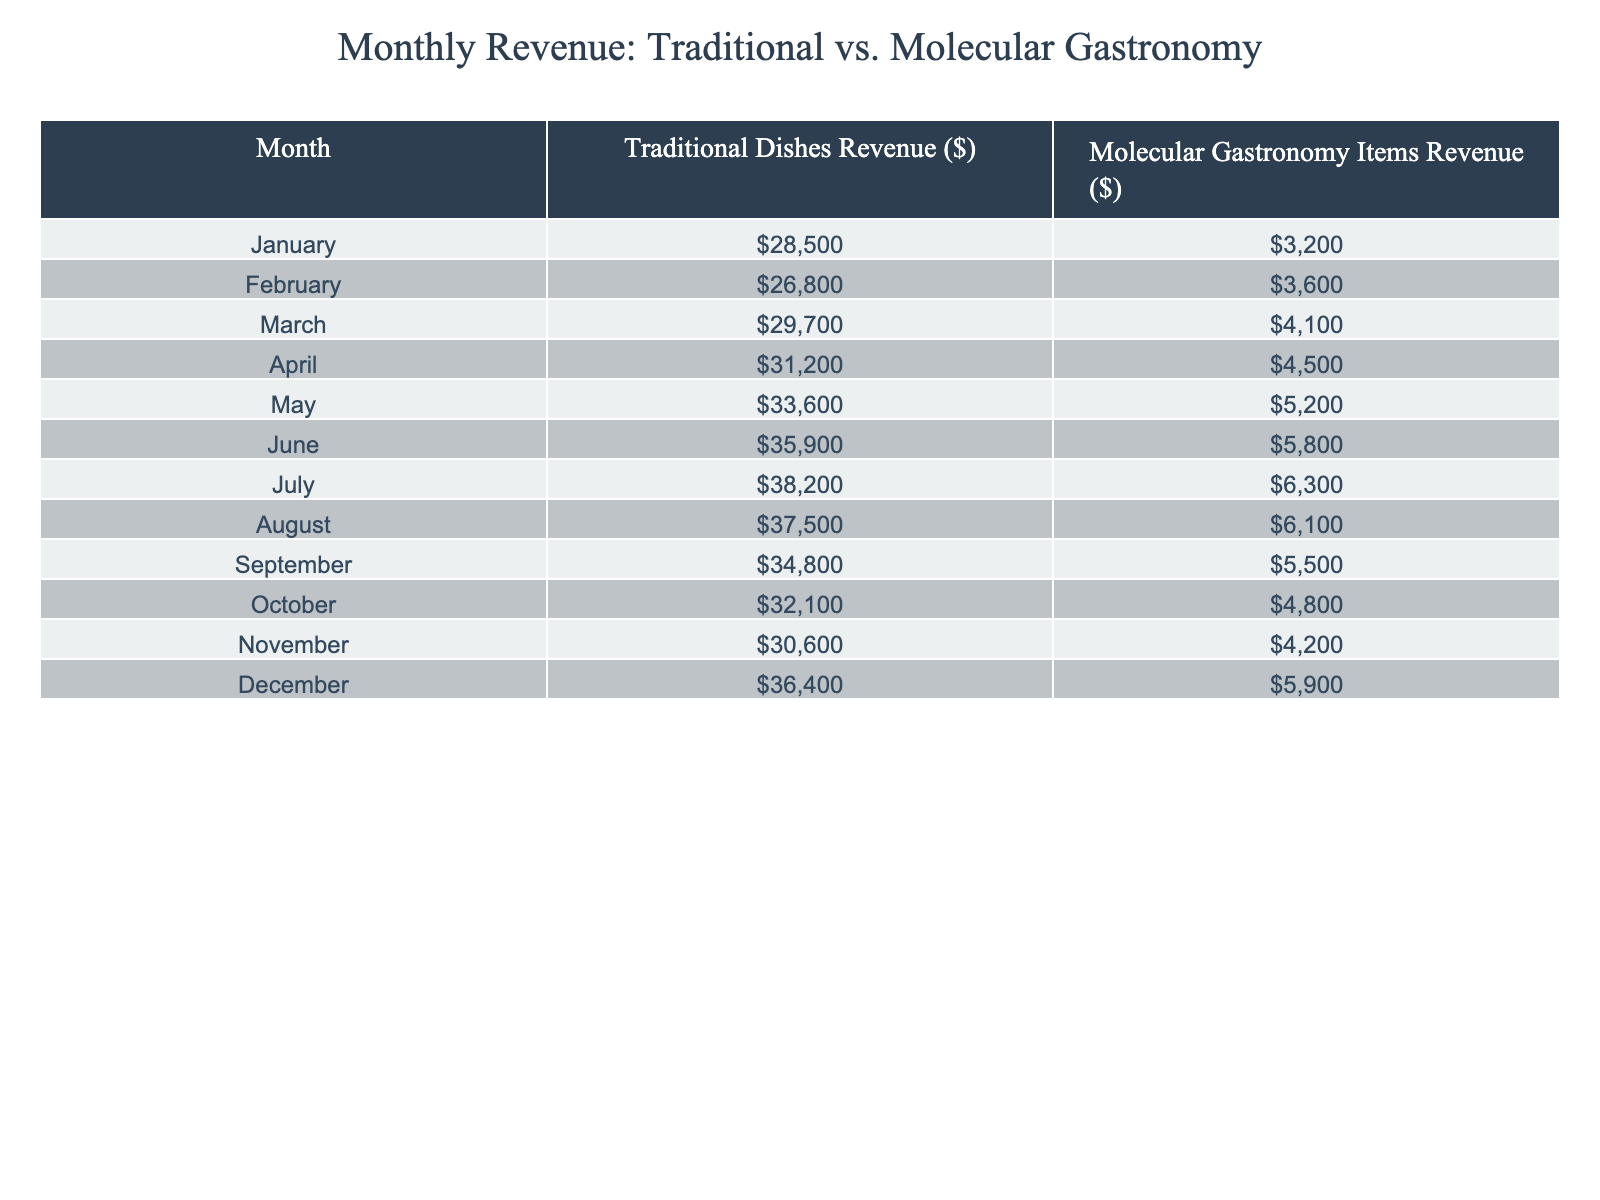What was the highest revenue month for traditional dishes? Looking at the data, the month with the highest revenue for traditional dishes is June, with a revenue of $35,900.
Answer: June What was the revenue of molecular gastronomy items in October? Referring to the table, the revenue for molecular gastronomy items in October is $4,800.
Answer: $4,800 What is the total revenue for traditional dishes over the entire year? To find the total revenue for traditional dishes, sum the monthly revenues: $28,500 + $26,800 + $29,700 + $31,200 + $33,600 + $35,900 + $38,200 + $37,500 + $34,800 + $32,100 + $30,600 + $36,400 = $401,400.
Answer: $401,400 What was the difference in revenue between traditional dishes and molecular gastronomy items in July? In July, the revenue for traditional dishes is $38,200 and for molecular gastronomy items is $6,300. The difference is $38,200 - $6,300 = $31,900.
Answer: $31,900 Which month had the least revenue for molecular gastronomy items? The least revenue for molecular gastronomy items was in January, with $3,200.
Answer: January What was the average monthly revenue for traditional dishes over the twelve months? To calculate the average, sum the revenues ($401,400) and divide by 12 months: $401,400 / 12 = $33,450.
Answer: $33,450 Is the revenue from molecular gastronomy items in May greater than that in April? In May, the revenue is $5,200, while in April it is $4,500. Since $5,200 > $4,500, the statement is true.
Answer: Yes What is the total revenue from molecular gastronomy items for the second half of the year (July to December)? The total revenue from July to December is calculated as: $6,300 (July) + $6,100 (August) + $5,500 (September) + $4,800 (October) + $4,200 (November) + $5,900 (December) = $32,900.
Answer: $32,900 In which month was the increase in revenue for traditional dishes compared to the previous month the largest? The largest increase can be found by comparing the monthly revenues: April ($31,200) - March ($29,700) = $1,500. The largest increase occurs from May ($33,600) to June ($35,900), which is $2,300.
Answer: June Which category had a higher total revenue across the year: traditional dishes or molecular gastronomy? Traditional dishes had a total revenue of $401,400, while molecular gastronomy had a total of $56,900 ($3,200 + $3,600 + $4,100 + $4,500 + $5,200 + $5,800 + $6,300 + $6,100 + $5,500 + $4,800 + $4,200 + $5,900 = $56,900). Traditional dishes had a higher total revenue.
Answer: Traditional dishes 